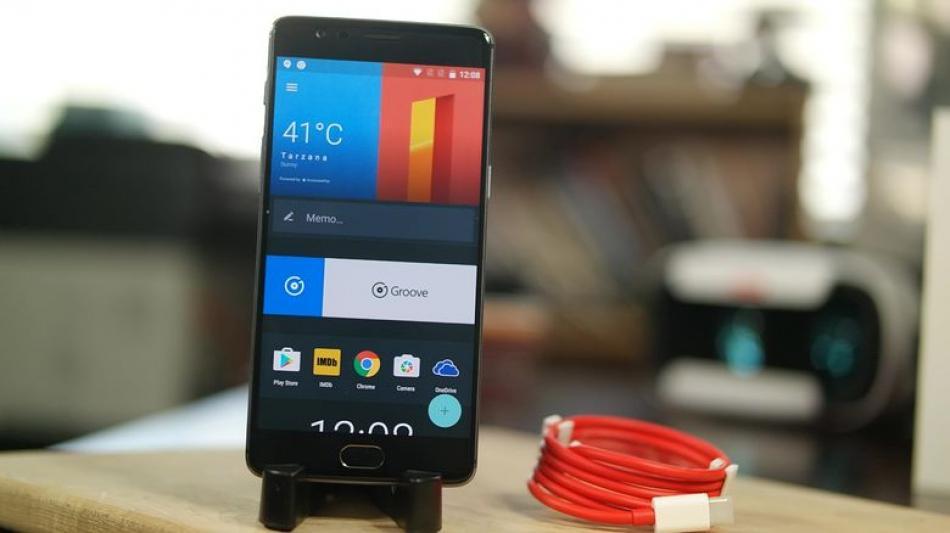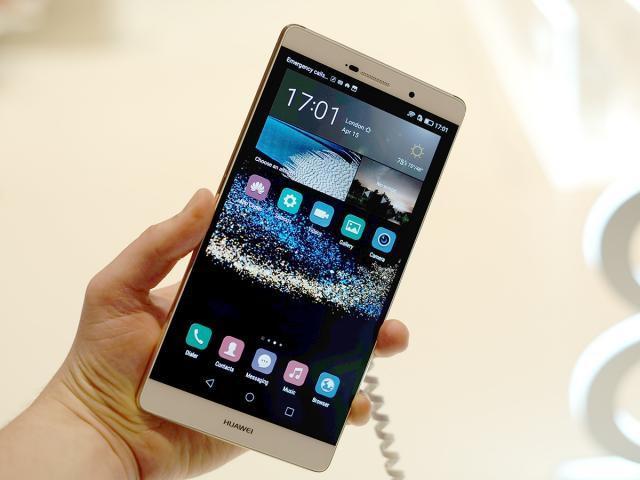The first image is the image on the left, the second image is the image on the right. For the images displayed, is the sentence "There are two phones and one hand." factually correct? Answer yes or no. Yes. The first image is the image on the left, the second image is the image on the right. Examine the images to the left and right. Is the description "There are three hands." accurate? Answer yes or no. No. 